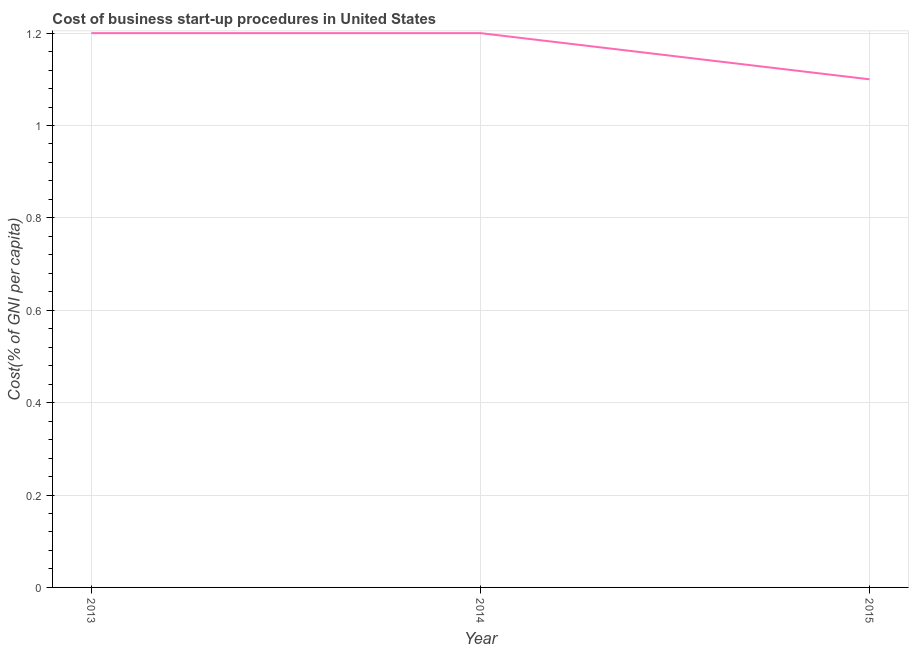In which year was the cost of business startup procedures minimum?
Provide a succinct answer. 2015. What is the difference between the cost of business startup procedures in 2013 and 2015?
Provide a short and direct response. 0.1. What is the average cost of business startup procedures per year?
Provide a succinct answer. 1.17. What is the median cost of business startup procedures?
Keep it short and to the point. 1.2. In how many years, is the cost of business startup procedures greater than 0.44 %?
Make the answer very short. 3. What is the ratio of the cost of business startup procedures in 2013 to that in 2015?
Offer a terse response. 1.09. Is the cost of business startup procedures in 2013 less than that in 2014?
Your answer should be very brief. No. Is the difference between the cost of business startup procedures in 2013 and 2015 greater than the difference between any two years?
Provide a short and direct response. Yes. What is the difference between the highest and the lowest cost of business startup procedures?
Make the answer very short. 0.1. In how many years, is the cost of business startup procedures greater than the average cost of business startup procedures taken over all years?
Offer a very short reply. 2. Does the cost of business startup procedures monotonically increase over the years?
Make the answer very short. No. How many lines are there?
Offer a very short reply. 1. Are the values on the major ticks of Y-axis written in scientific E-notation?
Keep it short and to the point. No. Does the graph contain any zero values?
Ensure brevity in your answer.  No. Does the graph contain grids?
Your answer should be compact. Yes. What is the title of the graph?
Your response must be concise. Cost of business start-up procedures in United States. What is the label or title of the Y-axis?
Ensure brevity in your answer.  Cost(% of GNI per capita). What is the Cost(% of GNI per capita) of 2014?
Give a very brief answer. 1.2. What is the Cost(% of GNI per capita) in 2015?
Make the answer very short. 1.1. What is the difference between the Cost(% of GNI per capita) in 2013 and 2015?
Offer a terse response. 0.1. What is the ratio of the Cost(% of GNI per capita) in 2013 to that in 2014?
Your response must be concise. 1. What is the ratio of the Cost(% of GNI per capita) in 2013 to that in 2015?
Make the answer very short. 1.09. What is the ratio of the Cost(% of GNI per capita) in 2014 to that in 2015?
Make the answer very short. 1.09. 